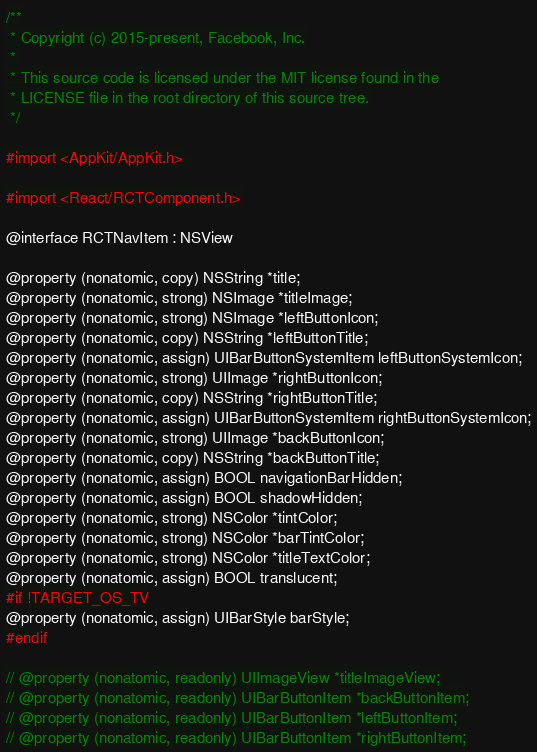<code> <loc_0><loc_0><loc_500><loc_500><_C_>/**
 * Copyright (c) 2015-present, Facebook, Inc.
 *
 * This source code is licensed under the MIT license found in the
 * LICENSE file in the root directory of this source tree.
 */

#import <AppKit/AppKit.h>

#import <React/RCTComponent.h>

@interface RCTNavItem : NSView

@property (nonatomic, copy) NSString *title;
@property (nonatomic, strong) NSImage *titleImage;
@property (nonatomic, strong) NSImage *leftButtonIcon;
@property (nonatomic, copy) NSString *leftButtonTitle;
@property (nonatomic, assign) UIBarButtonSystemItem leftButtonSystemIcon;
@property (nonatomic, strong) UIImage *rightButtonIcon;
@property (nonatomic, copy) NSString *rightButtonTitle;
@property (nonatomic, assign) UIBarButtonSystemItem rightButtonSystemIcon;
@property (nonatomic, strong) UIImage *backButtonIcon;
@property (nonatomic, copy) NSString *backButtonTitle;
@property (nonatomic, assign) BOOL navigationBarHidden;
@property (nonatomic, assign) BOOL shadowHidden;
@property (nonatomic, strong) NSColor *tintColor;
@property (nonatomic, strong) NSColor *barTintColor;
@property (nonatomic, strong) NSColor *titleTextColor;
@property (nonatomic, assign) BOOL translucent;
#if !TARGET_OS_TV
@property (nonatomic, assign) UIBarStyle barStyle;
#endif

// @property (nonatomic, readonly) UIImageView *titleImageView;
// @property (nonatomic, readonly) UIBarButtonItem *backButtonItem;
// @property (nonatomic, readonly) UIBarButtonItem *leftButtonItem;
// @property (nonatomic, readonly) UIBarButtonItem *rightButtonItem;
</code> 